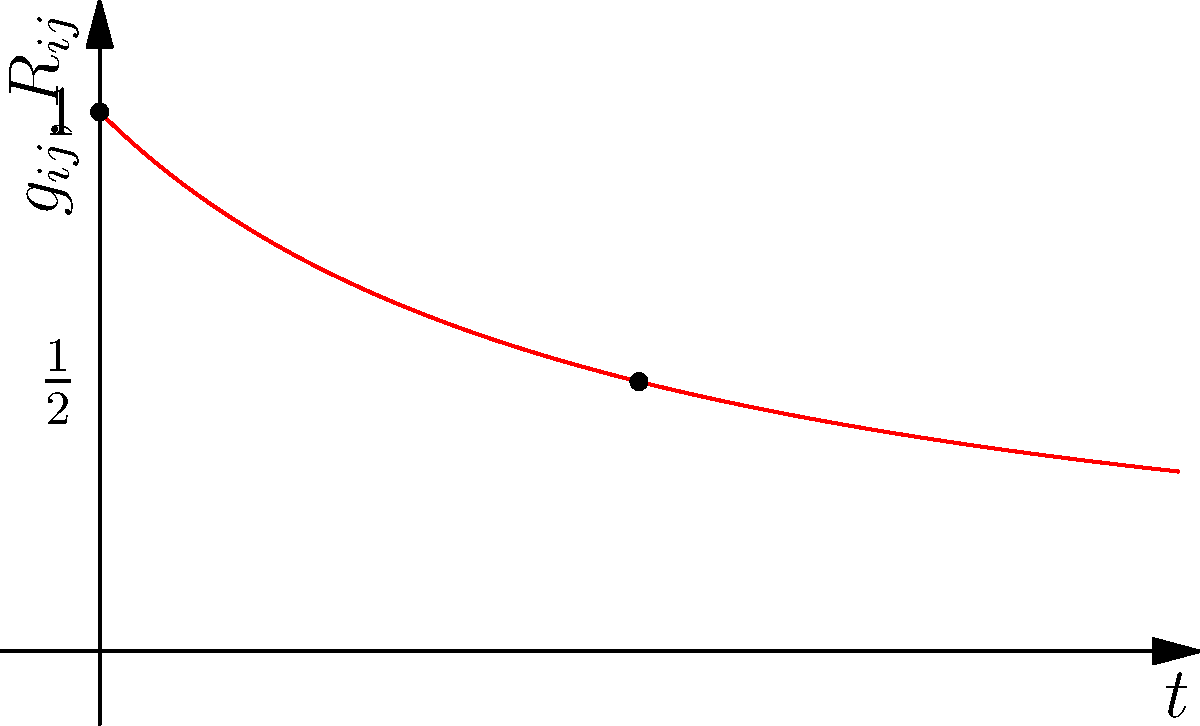Consider the Ricci flow on a 2-dimensional sphere, given by the equation:

$$ \frac{\partial}{\partial t} g_{ij} = -2R_{ij} $$

Where $g_{ij}$ is the metric tensor and $R_{ij}$ is the Ricci curvature tensor. The graph shows the evolution of $g_{ij}(t)$ and $R_{ij}(t)$ over time. What geometric interpretation can be derived about the behavior of the sphere under this Ricci flow, and at what time $t$ does the flow encounter a singularity? To interpret the geometric behavior of the sphere under the Ricci flow and determine the singularity time, we need to analyze the graph and the given equation:

1) The blue curve represents $g_{ij}(t)$, which is decreasing over time. This indicates that the metric is shrinking.

2) The red curve represents $R_{ij}(t)$, which is also decreasing but at a slower rate than $g_{ij}(t)$.

3) From the Ricci flow equation, we can see that the rate of change of $g_{ij}$ is proportional to $-R_{ij}$. This explains why both curves are decreasing.

4) For a sphere, the Ricci curvature is positive and proportional to the metric. As the metric shrinks, the curvature increases, causing the sphere to shrink faster.

5) The singularity occurs when the metric becomes degenerate, i.e., when $g_{ij}(t) = 0$. From the graph, we can see that this happens as $t$ approaches 2.

6) We can verify this analytically. The solution for the metric on a sphere under Ricci flow is:

   $$ g_{ij}(t) = \frac{1}{1+t}g_{ij}(0) $$

   This matches the blue curve in the graph.

7) The singularity time $T$ is when $g_{ij}(T) = 0$, which gives:

   $$ \frac{1}{1+T} = 0 $$
   $$ T = 2 $$

Therefore, the geometric interpretation is that the sphere shrinks uniformly, becoming smaller and more curved over time, until it collapses to a point at $t = 2$.
Answer: Sphere shrinks uniformly, collapsing to a point at $t = 2$. 